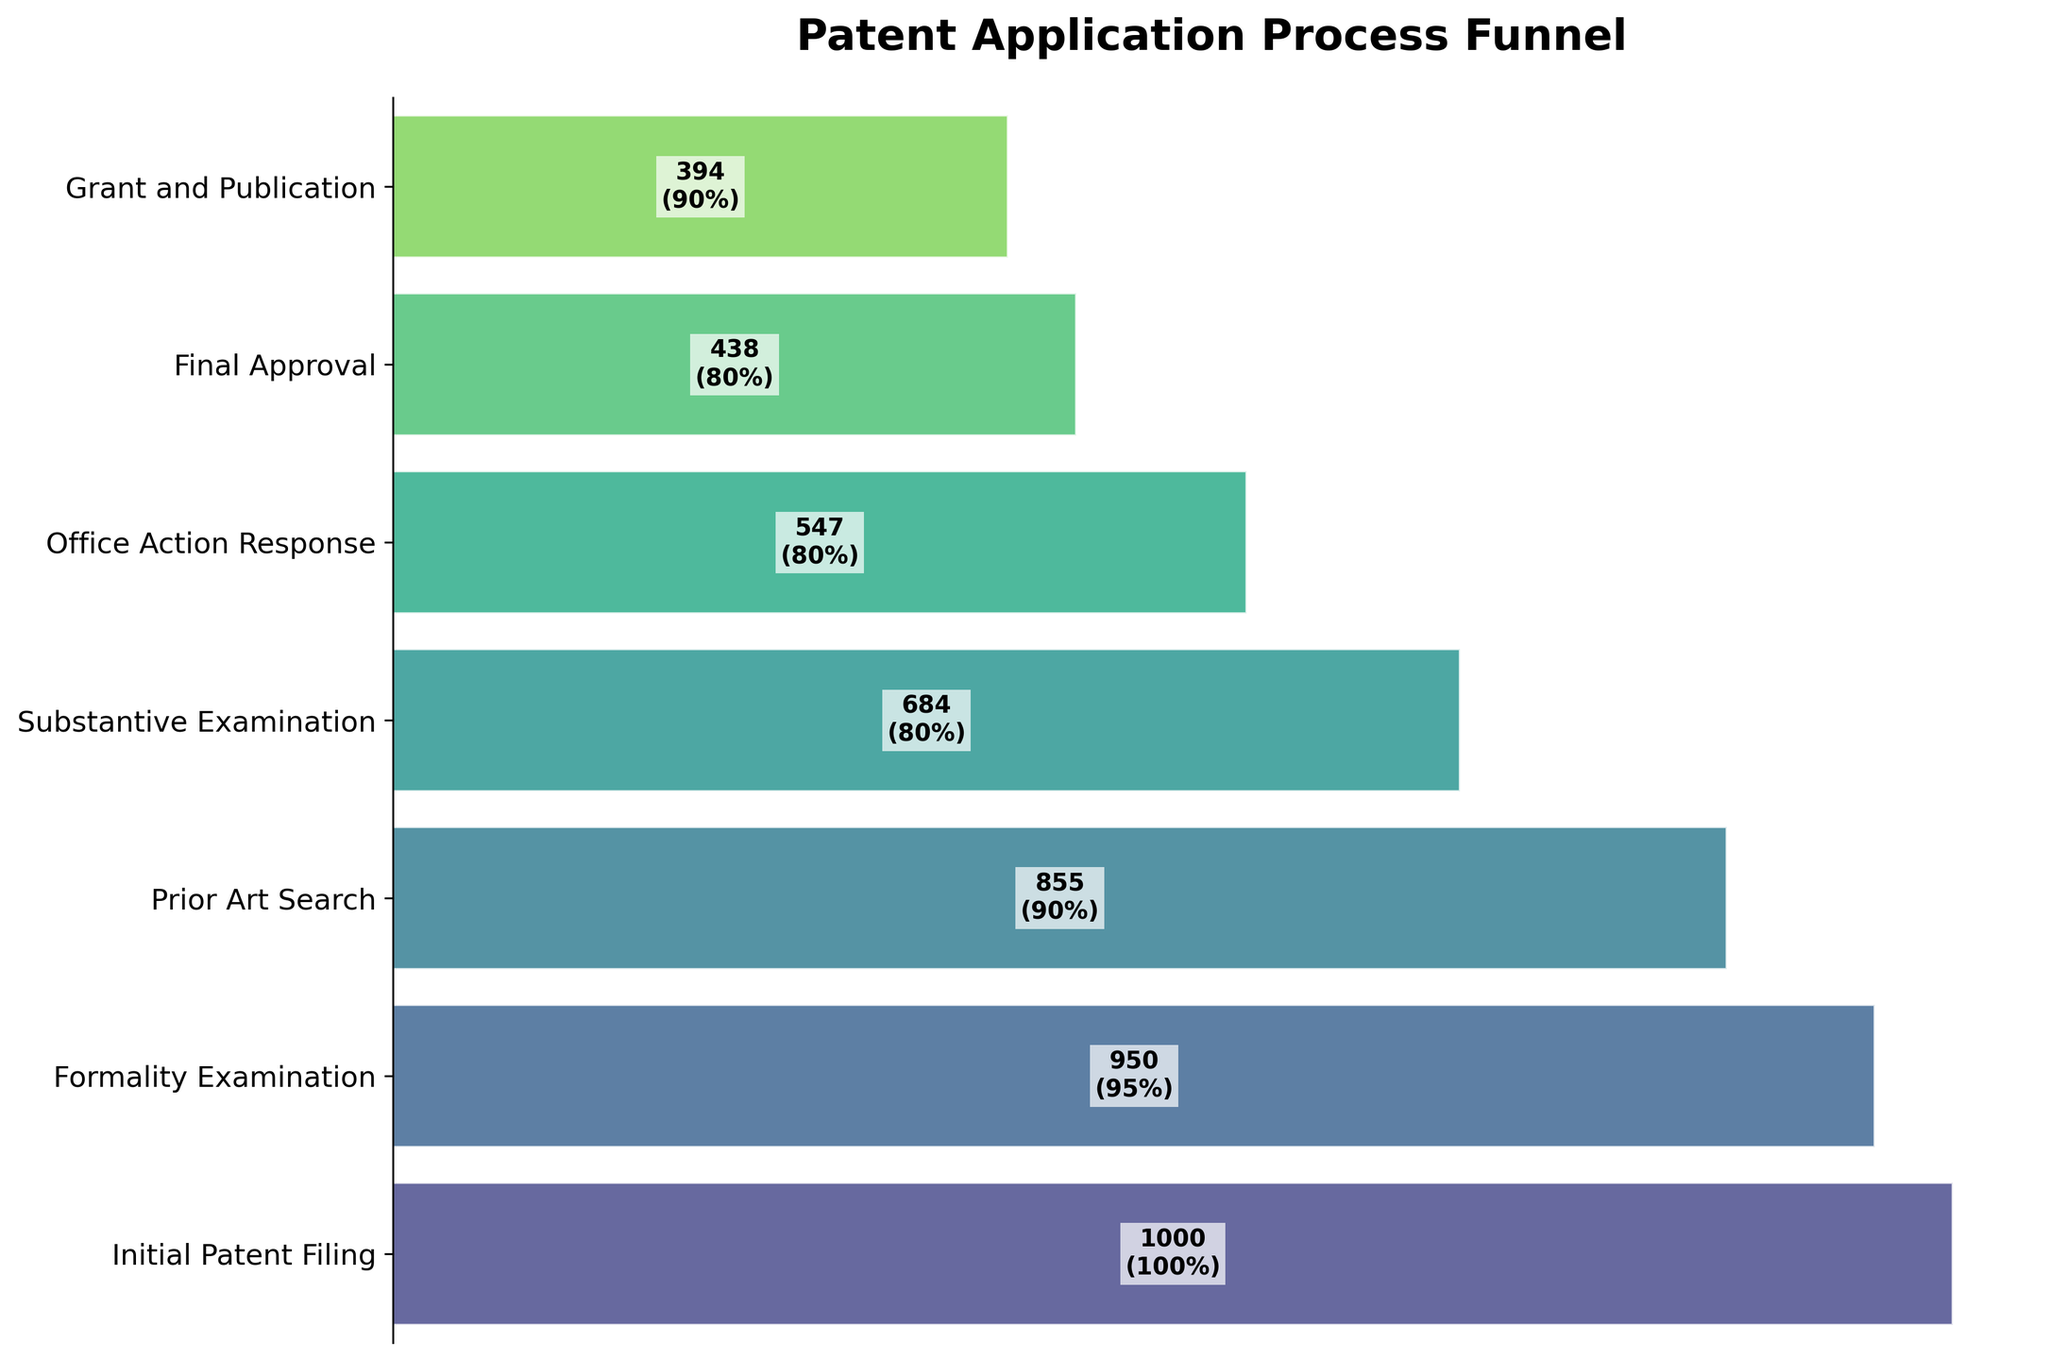What is the title of the figure? The title of the figure is displayed at the top and often provides a summary of the visual information being presented. Here, the title reads "Patent Application Process Funnel," which indicates the focus of the visualization on the stages of the patent application.
Answer: Patent Application Process Funnel How many steps are there in the patent application process? To determine the number of steps, look at the y-axis, where each step in the process is listed. Count these steps to find the total number.
Answer: 7 What step has the highest number of applications? To find the step with the highest number of applications, compare the numerical values associated with each step. The first step, "Initial Patent Filing," has 1000 applications, the highest among all steps.
Answer: Initial Patent Filing What is the percentage drop in the number of applications from "Formality Examination" to "Prior Art Search"? Calculate this by first determining the number of applications at both steps: 950 at "Formality Examination" and 855 at "Prior Art Search". Then, compute the percentage drop: (950 - 855) / 950 * 100.
Answer: 10% How many applications are granted and published? Look for the number of applications at the last step of the process, "Grant and Publication," which shows the final count. This number is found directly from the right end of the funnel figure.
Answer: 394 What is the approval rate for the Substantive Examination step? The approval rate is indicated next to each step. Look for the value next to "Substantive Examination," which states the approval rate as 80%.
Answer: 80% Which step has the second lowest approval rate and what is it? Compare the approval rates of each step. The second lowest approval rate is for the "Office Action Response" step, which has an approval rate of 80%, slightly higher than "Substantive Examination."
Answer: Office Action Response, 80% From "Initial Patent Filing" to "Grant and Publication," what is the total reduction in the number of applications? Begin with the initial number of applications (1000) and subtract the number of applications at "Grant and Publication" (394). The total reduction is 1000 - 394.
Answer: 606 Which step experiences the smallest reduction in the number of applications? Calculate the reduction between steps and find the smallest difference. The reduction between "Office Action Response" (547) and "Final Approval" (438) is 547 - 438 = 109, the smallest reduction among the steps.
Answer: Office Action Response to Final Approval Which step has the highest approval rate, and what is its value? Compare the approval rates for each step. The highest approval rate is at the "Grant and Publication" step, which is 90%.
Answer: Grant and Publication, 90% 